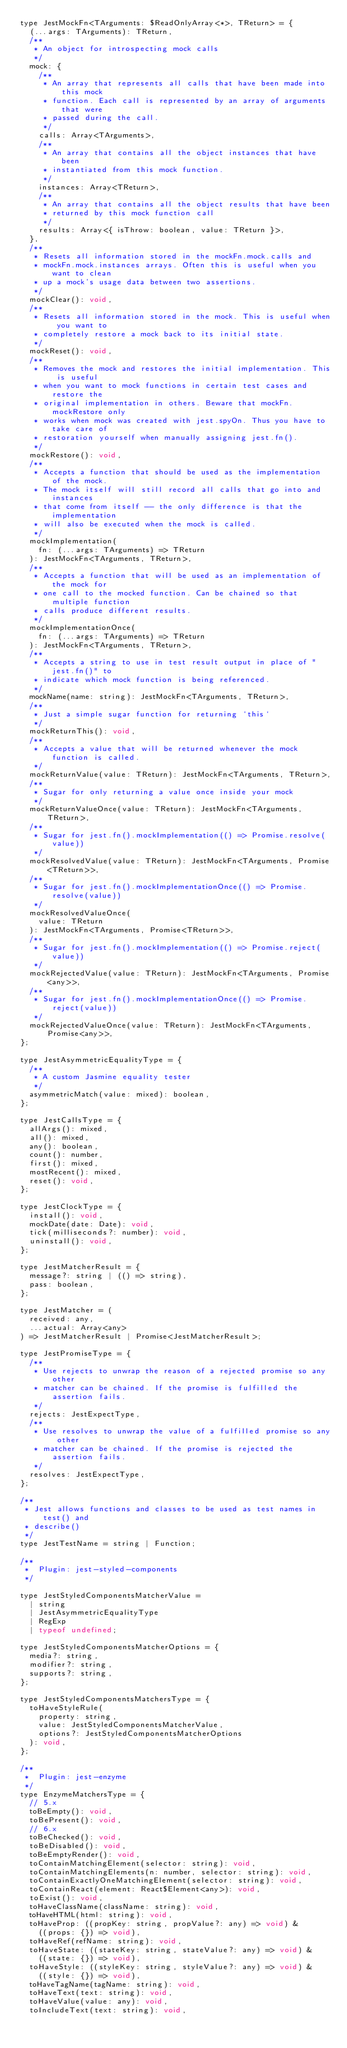Convert code to text. <code><loc_0><loc_0><loc_500><loc_500><_JavaScript_>type JestMockFn<TArguments: $ReadOnlyArray<*>, TReturn> = {
  (...args: TArguments): TReturn,
  /**
   * An object for introspecting mock calls
   */
  mock: {
    /**
     * An array that represents all calls that have been made into this mock
     * function. Each call is represented by an array of arguments that were
     * passed during the call.
     */
    calls: Array<TArguments>,
    /**
     * An array that contains all the object instances that have been
     * instantiated from this mock function.
     */
    instances: Array<TReturn>,
    /**
     * An array that contains all the object results that have been
     * returned by this mock function call
     */
    results: Array<{ isThrow: boolean, value: TReturn }>,
  },
  /**
   * Resets all information stored in the mockFn.mock.calls and
   * mockFn.mock.instances arrays. Often this is useful when you want to clean
   * up a mock's usage data between two assertions.
   */
  mockClear(): void,
  /**
   * Resets all information stored in the mock. This is useful when you want to
   * completely restore a mock back to its initial state.
   */
  mockReset(): void,
  /**
   * Removes the mock and restores the initial implementation. This is useful
   * when you want to mock functions in certain test cases and restore the
   * original implementation in others. Beware that mockFn.mockRestore only
   * works when mock was created with jest.spyOn. Thus you have to take care of
   * restoration yourself when manually assigning jest.fn().
   */
  mockRestore(): void,
  /**
   * Accepts a function that should be used as the implementation of the mock.
   * The mock itself will still record all calls that go into and instances
   * that come from itself -- the only difference is that the implementation
   * will also be executed when the mock is called.
   */
  mockImplementation(
    fn: (...args: TArguments) => TReturn
  ): JestMockFn<TArguments, TReturn>,
  /**
   * Accepts a function that will be used as an implementation of the mock for
   * one call to the mocked function. Can be chained so that multiple function
   * calls produce different results.
   */
  mockImplementationOnce(
    fn: (...args: TArguments) => TReturn
  ): JestMockFn<TArguments, TReturn>,
  /**
   * Accepts a string to use in test result output in place of "jest.fn()" to
   * indicate which mock function is being referenced.
   */
  mockName(name: string): JestMockFn<TArguments, TReturn>,
  /**
   * Just a simple sugar function for returning `this`
   */
  mockReturnThis(): void,
  /**
   * Accepts a value that will be returned whenever the mock function is called.
   */
  mockReturnValue(value: TReturn): JestMockFn<TArguments, TReturn>,
  /**
   * Sugar for only returning a value once inside your mock
   */
  mockReturnValueOnce(value: TReturn): JestMockFn<TArguments, TReturn>,
  /**
   * Sugar for jest.fn().mockImplementation(() => Promise.resolve(value))
   */
  mockResolvedValue(value: TReturn): JestMockFn<TArguments, Promise<TReturn>>,
  /**
   * Sugar for jest.fn().mockImplementationOnce(() => Promise.resolve(value))
   */
  mockResolvedValueOnce(
    value: TReturn
  ): JestMockFn<TArguments, Promise<TReturn>>,
  /**
   * Sugar for jest.fn().mockImplementation(() => Promise.reject(value))
   */
  mockRejectedValue(value: TReturn): JestMockFn<TArguments, Promise<any>>,
  /**
   * Sugar for jest.fn().mockImplementationOnce(() => Promise.reject(value))
   */
  mockRejectedValueOnce(value: TReturn): JestMockFn<TArguments, Promise<any>>,
};

type JestAsymmetricEqualityType = {
  /**
   * A custom Jasmine equality tester
   */
  asymmetricMatch(value: mixed): boolean,
};

type JestCallsType = {
  allArgs(): mixed,
  all(): mixed,
  any(): boolean,
  count(): number,
  first(): mixed,
  mostRecent(): mixed,
  reset(): void,
};

type JestClockType = {
  install(): void,
  mockDate(date: Date): void,
  tick(milliseconds?: number): void,
  uninstall(): void,
};

type JestMatcherResult = {
  message?: string | (() => string),
  pass: boolean,
};

type JestMatcher = (
  received: any,
  ...actual: Array<any>
) => JestMatcherResult | Promise<JestMatcherResult>;

type JestPromiseType = {
  /**
   * Use rejects to unwrap the reason of a rejected promise so any other
   * matcher can be chained. If the promise is fulfilled the assertion fails.
   */
  rejects: JestExpectType,
  /**
   * Use resolves to unwrap the value of a fulfilled promise so any other
   * matcher can be chained. If the promise is rejected the assertion fails.
   */
  resolves: JestExpectType,
};

/**
 * Jest allows functions and classes to be used as test names in test() and
 * describe()
 */
type JestTestName = string | Function;

/**
 *  Plugin: jest-styled-components
 */

type JestStyledComponentsMatcherValue =
  | string
  | JestAsymmetricEqualityType
  | RegExp
  | typeof undefined;

type JestStyledComponentsMatcherOptions = {
  media?: string,
  modifier?: string,
  supports?: string,
};

type JestStyledComponentsMatchersType = {
  toHaveStyleRule(
    property: string,
    value: JestStyledComponentsMatcherValue,
    options?: JestStyledComponentsMatcherOptions
  ): void,
};

/**
 *  Plugin: jest-enzyme
 */
type EnzymeMatchersType = {
  // 5.x
  toBeEmpty(): void,
  toBePresent(): void,
  // 6.x
  toBeChecked(): void,
  toBeDisabled(): void,
  toBeEmptyRender(): void,
  toContainMatchingElement(selector: string): void,
  toContainMatchingElements(n: number, selector: string): void,
  toContainExactlyOneMatchingElement(selector: string): void,
  toContainReact(element: React$Element<any>): void,
  toExist(): void,
  toHaveClassName(className: string): void,
  toHaveHTML(html: string): void,
  toHaveProp: ((propKey: string, propValue?: any) => void) &
    ((props: {}) => void),
  toHaveRef(refName: string): void,
  toHaveState: ((stateKey: string, stateValue?: any) => void) &
    ((state: {}) => void),
  toHaveStyle: ((styleKey: string, styleValue?: any) => void) &
    ((style: {}) => void),
  toHaveTagName(tagName: string): void,
  toHaveText(text: string): void,
  toHaveValue(value: any): void,
  toIncludeText(text: string): void,</code> 